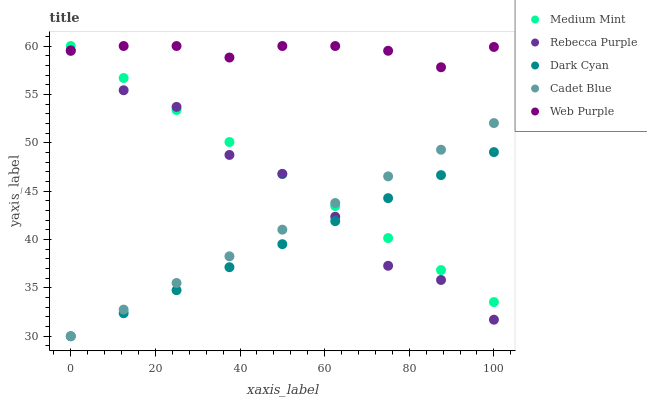Does Dark Cyan have the minimum area under the curve?
Answer yes or no. Yes. Does Web Purple have the maximum area under the curve?
Answer yes or no. Yes. Does Web Purple have the minimum area under the curve?
Answer yes or no. No. Does Dark Cyan have the maximum area under the curve?
Answer yes or no. No. Is Medium Mint the smoothest?
Answer yes or no. Yes. Is Rebecca Purple the roughest?
Answer yes or no. Yes. Is Dark Cyan the smoothest?
Answer yes or no. No. Is Dark Cyan the roughest?
Answer yes or no. No. Does Dark Cyan have the lowest value?
Answer yes or no. Yes. Does Web Purple have the lowest value?
Answer yes or no. No. Does Web Purple have the highest value?
Answer yes or no. Yes. Does Dark Cyan have the highest value?
Answer yes or no. No. Is Rebecca Purple less than Web Purple?
Answer yes or no. Yes. Is Web Purple greater than Cadet Blue?
Answer yes or no. Yes. Does Medium Mint intersect Dark Cyan?
Answer yes or no. Yes. Is Medium Mint less than Dark Cyan?
Answer yes or no. No. Is Medium Mint greater than Dark Cyan?
Answer yes or no. No. Does Rebecca Purple intersect Web Purple?
Answer yes or no. No. 